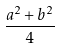Convert formula to latex. <formula><loc_0><loc_0><loc_500><loc_500>\frac { a ^ { 2 } + b ^ { 2 } } { 4 }</formula> 